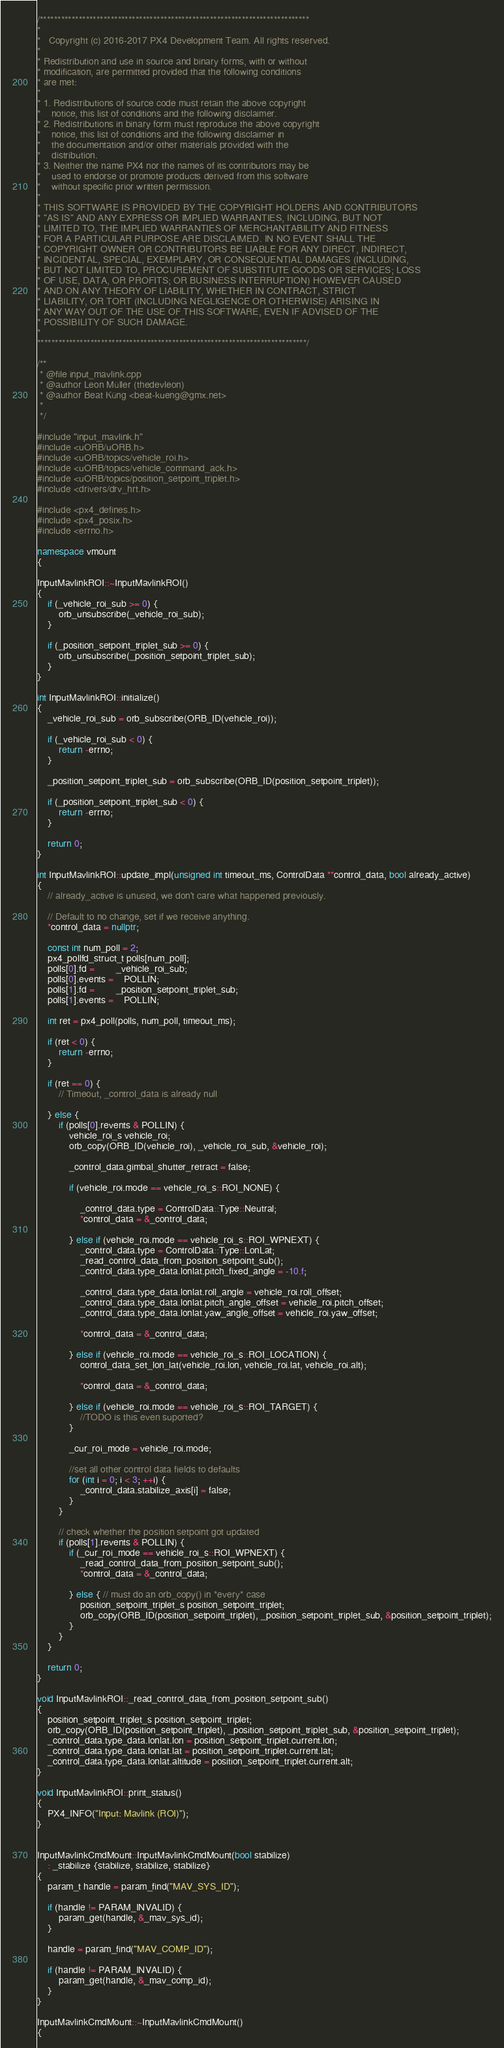Convert code to text. <code><loc_0><loc_0><loc_500><loc_500><_C++_>/****************************************************************************
*
*   Copyright (c) 2016-2017 PX4 Development Team. All rights reserved.
*
* Redistribution and use in source and binary forms, with or without
* modification, are permitted provided that the following conditions
* are met:
*
* 1. Redistributions of source code must retain the above copyright
*    notice, this list of conditions and the following disclaimer.
* 2. Redistributions in binary form must reproduce the above copyright
*    notice, this list of conditions and the following disclaimer in
*    the documentation and/or other materials provided with the
*    distribution.
* 3. Neither the name PX4 nor the names of its contributors may be
*    used to endorse or promote products derived from this software
*    without specific prior written permission.
*
* THIS SOFTWARE IS PROVIDED BY THE COPYRIGHT HOLDERS AND CONTRIBUTORS
* "AS IS" AND ANY EXPRESS OR IMPLIED WARRANTIES, INCLUDING, BUT NOT
* LIMITED TO, THE IMPLIED WARRANTIES OF MERCHANTABILITY AND FITNESS
* FOR A PARTICULAR PURPOSE ARE DISCLAIMED. IN NO EVENT SHALL THE
* COPYRIGHT OWNER OR CONTRIBUTORS BE LIABLE FOR ANY DIRECT, INDIRECT,
* INCIDENTAL, SPECIAL, EXEMPLARY, OR CONSEQUENTIAL DAMAGES (INCLUDING,
* BUT NOT LIMITED TO, PROCUREMENT OF SUBSTITUTE GOODS OR SERVICES; LOSS
* OF USE, DATA, OR PROFITS; OR BUSINESS INTERRUPTION) HOWEVER CAUSED
* AND ON ANY THEORY OF LIABILITY, WHETHER IN CONTRACT, STRICT
* LIABILITY, OR TORT (INCLUDING NEGLIGENCE OR OTHERWISE) ARISING IN
* ANY WAY OUT OF THE USE OF THIS SOFTWARE, EVEN IF ADVISED OF THE
* POSSIBILITY OF SUCH DAMAGE.
*
****************************************************************************/

/**
 * @file input_mavlink.cpp
 * @author Leon Müller (thedevleon)
 * @author Beat Küng <beat-kueng@gmx.net>
 *
 */

#include "input_mavlink.h"
#include <uORB/uORB.h>
#include <uORB/topics/vehicle_roi.h>
#include <uORB/topics/vehicle_command_ack.h>
#include <uORB/topics/position_setpoint_triplet.h>
#include <drivers/drv_hrt.h>

#include <px4_defines.h>
#include <px4_posix.h>
#include <errno.h>

namespace vmount
{

InputMavlinkROI::~InputMavlinkROI()
{
	if (_vehicle_roi_sub >= 0) {
		orb_unsubscribe(_vehicle_roi_sub);
	}

	if (_position_setpoint_triplet_sub >= 0) {
		orb_unsubscribe(_position_setpoint_triplet_sub);
	}
}

int InputMavlinkROI::initialize()
{
	_vehicle_roi_sub = orb_subscribe(ORB_ID(vehicle_roi));

	if (_vehicle_roi_sub < 0) {
		return -errno;
	}

	_position_setpoint_triplet_sub = orb_subscribe(ORB_ID(position_setpoint_triplet));

	if (_position_setpoint_triplet_sub < 0) {
		return -errno;
	}

	return 0;
}

int InputMavlinkROI::update_impl(unsigned int timeout_ms, ControlData **control_data, bool already_active)
{
	// already_active is unused, we don't care what happened previously.

	// Default to no change, set if we receive anything.
	*control_data = nullptr;

	const int num_poll = 2;
	px4_pollfd_struct_t polls[num_poll];
	polls[0].fd = 		_vehicle_roi_sub;
	polls[0].events = 	POLLIN;
	polls[1].fd = 		_position_setpoint_triplet_sub;
	polls[1].events = 	POLLIN;

	int ret = px4_poll(polls, num_poll, timeout_ms);

	if (ret < 0) {
		return -errno;
	}

	if (ret == 0) {
		// Timeout, _control_data is already null

	} else {
		if (polls[0].revents & POLLIN) {
			vehicle_roi_s vehicle_roi;
			orb_copy(ORB_ID(vehicle_roi), _vehicle_roi_sub, &vehicle_roi);

			_control_data.gimbal_shutter_retract = false;

			if (vehicle_roi.mode == vehicle_roi_s::ROI_NONE) {

				_control_data.type = ControlData::Type::Neutral;
				*control_data = &_control_data;

			} else if (vehicle_roi.mode == vehicle_roi_s::ROI_WPNEXT) {
				_control_data.type = ControlData::Type::LonLat;
				_read_control_data_from_position_setpoint_sub();
				_control_data.type_data.lonlat.pitch_fixed_angle = -10.f;

				_control_data.type_data.lonlat.roll_angle = vehicle_roi.roll_offset;
				_control_data.type_data.lonlat.pitch_angle_offset = vehicle_roi.pitch_offset;
				_control_data.type_data.lonlat.yaw_angle_offset = vehicle_roi.yaw_offset;

				*control_data = &_control_data;

			} else if (vehicle_roi.mode == vehicle_roi_s::ROI_LOCATION) {
				control_data_set_lon_lat(vehicle_roi.lon, vehicle_roi.lat, vehicle_roi.alt);

				*control_data = &_control_data;

			} else if (vehicle_roi.mode == vehicle_roi_s::ROI_TARGET) {
				//TODO is this even suported?
			}

			_cur_roi_mode = vehicle_roi.mode;

			//set all other control data fields to defaults
			for (int i = 0; i < 3; ++i) {
				_control_data.stabilize_axis[i] = false;
			}
		}

		// check whether the position setpoint got updated
		if (polls[1].revents & POLLIN) {
			if (_cur_roi_mode == vehicle_roi_s::ROI_WPNEXT) {
				_read_control_data_from_position_setpoint_sub();
				*control_data = &_control_data;

			} else { // must do an orb_copy() in *every* case
				position_setpoint_triplet_s position_setpoint_triplet;
				orb_copy(ORB_ID(position_setpoint_triplet), _position_setpoint_triplet_sub, &position_setpoint_triplet);
			}
		}
	}

	return 0;
}

void InputMavlinkROI::_read_control_data_from_position_setpoint_sub()
{
	position_setpoint_triplet_s position_setpoint_triplet;
	orb_copy(ORB_ID(position_setpoint_triplet), _position_setpoint_triplet_sub, &position_setpoint_triplet);
	_control_data.type_data.lonlat.lon = position_setpoint_triplet.current.lon;
	_control_data.type_data.lonlat.lat = position_setpoint_triplet.current.lat;
	_control_data.type_data.lonlat.altitude = position_setpoint_triplet.current.alt;
}

void InputMavlinkROI::print_status()
{
	PX4_INFO("Input: Mavlink (ROI)");
}


InputMavlinkCmdMount::InputMavlinkCmdMount(bool stabilize)
	: _stabilize {stabilize, stabilize, stabilize}
{
	param_t handle = param_find("MAV_SYS_ID");

	if (handle != PARAM_INVALID) {
		param_get(handle, &_mav_sys_id);
	}

	handle = param_find("MAV_COMP_ID");

	if (handle != PARAM_INVALID) {
		param_get(handle, &_mav_comp_id);
	}
}

InputMavlinkCmdMount::~InputMavlinkCmdMount()
{</code> 